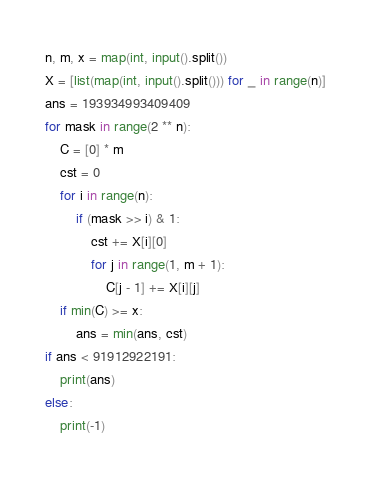<code> <loc_0><loc_0><loc_500><loc_500><_Python_>n, m, x = map(int, input().split())
X = [list(map(int, input().split())) for _ in range(n)]
ans = 193934993409409
for mask in range(2 ** n):
    C = [0] * m
    cst = 0
    for i in range(n):
        if (mask >> i) & 1:
            cst += X[i][0]
            for j in range(1, m + 1):
                C[j - 1] += X[i][j]
    if min(C) >= x:
        ans = min(ans, cst)
if ans < 91912922191:
    print(ans)
else:
    print(-1)</code> 